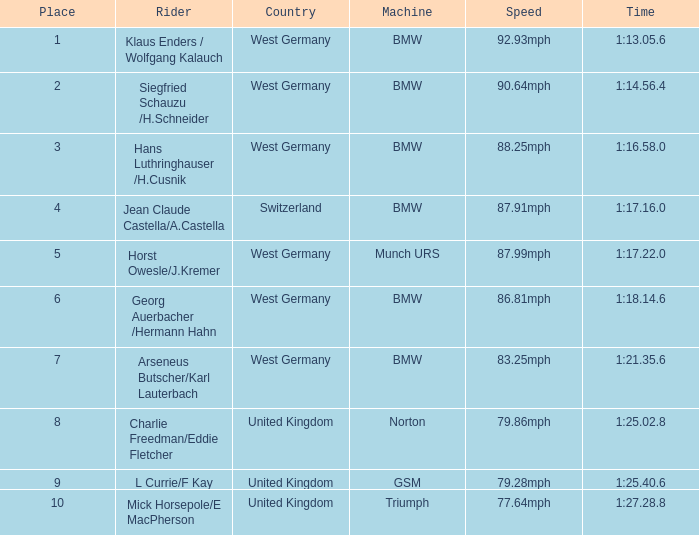Where can points exceeding 10 be found? None. 